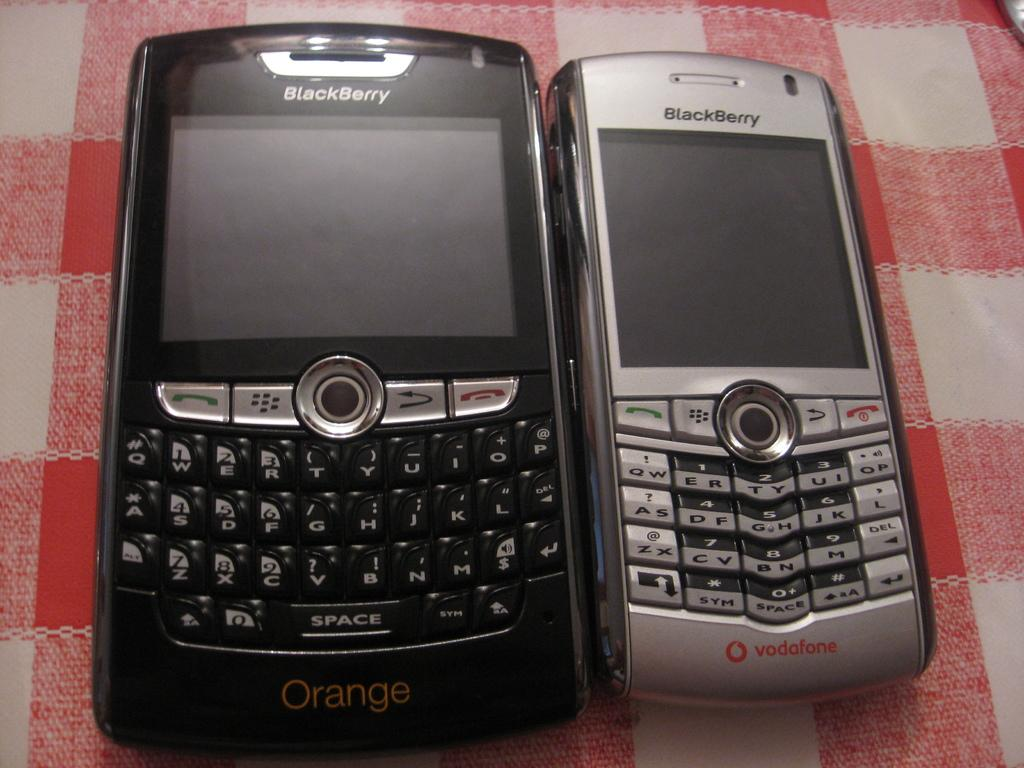<image>
Offer a succinct explanation of the picture presented. Two blackberry phones are on a red and white checkered tablecloth, the bigger one says Orange and the smaller one vodafone on the bottom. 